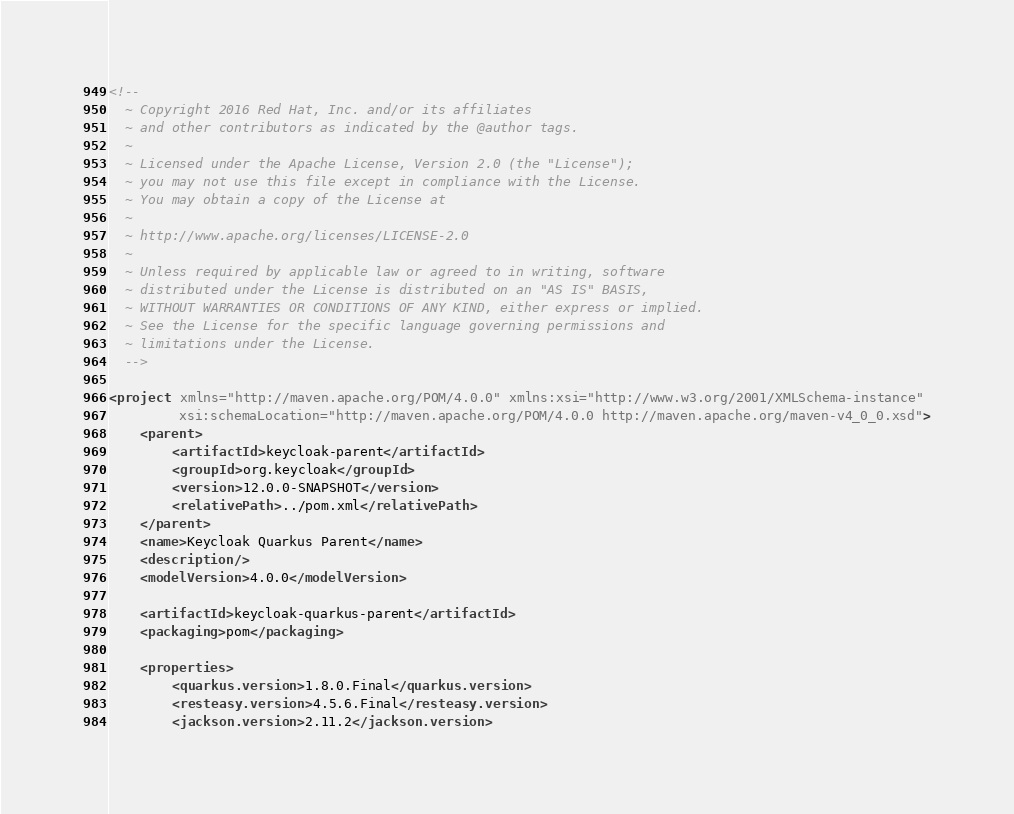Convert code to text. <code><loc_0><loc_0><loc_500><loc_500><_XML_><!--
  ~ Copyright 2016 Red Hat, Inc. and/or its affiliates
  ~ and other contributors as indicated by the @author tags.
  ~
  ~ Licensed under the Apache License, Version 2.0 (the "License");
  ~ you may not use this file except in compliance with the License.
  ~ You may obtain a copy of the License at
  ~
  ~ http://www.apache.org/licenses/LICENSE-2.0
  ~
  ~ Unless required by applicable law or agreed to in writing, software
  ~ distributed under the License is distributed on an "AS IS" BASIS,
  ~ WITHOUT WARRANTIES OR CONDITIONS OF ANY KIND, either express or implied.
  ~ See the License for the specific language governing permissions and
  ~ limitations under the License.
  -->

<project xmlns="http://maven.apache.org/POM/4.0.0" xmlns:xsi="http://www.w3.org/2001/XMLSchema-instance"
         xsi:schemaLocation="http://maven.apache.org/POM/4.0.0 http://maven.apache.org/maven-v4_0_0.xsd">
    <parent>
        <artifactId>keycloak-parent</artifactId>
        <groupId>org.keycloak</groupId>
        <version>12.0.0-SNAPSHOT</version>
        <relativePath>../pom.xml</relativePath>
    </parent>
    <name>Keycloak Quarkus Parent</name>
    <description/>
    <modelVersion>4.0.0</modelVersion>

    <artifactId>keycloak-quarkus-parent</artifactId>
    <packaging>pom</packaging>

    <properties>
        <quarkus.version>1.8.0.Final</quarkus.version>
        <resteasy.version>4.5.6.Final</resteasy.version>
        <jackson.version>2.11.2</jackson.version></code> 